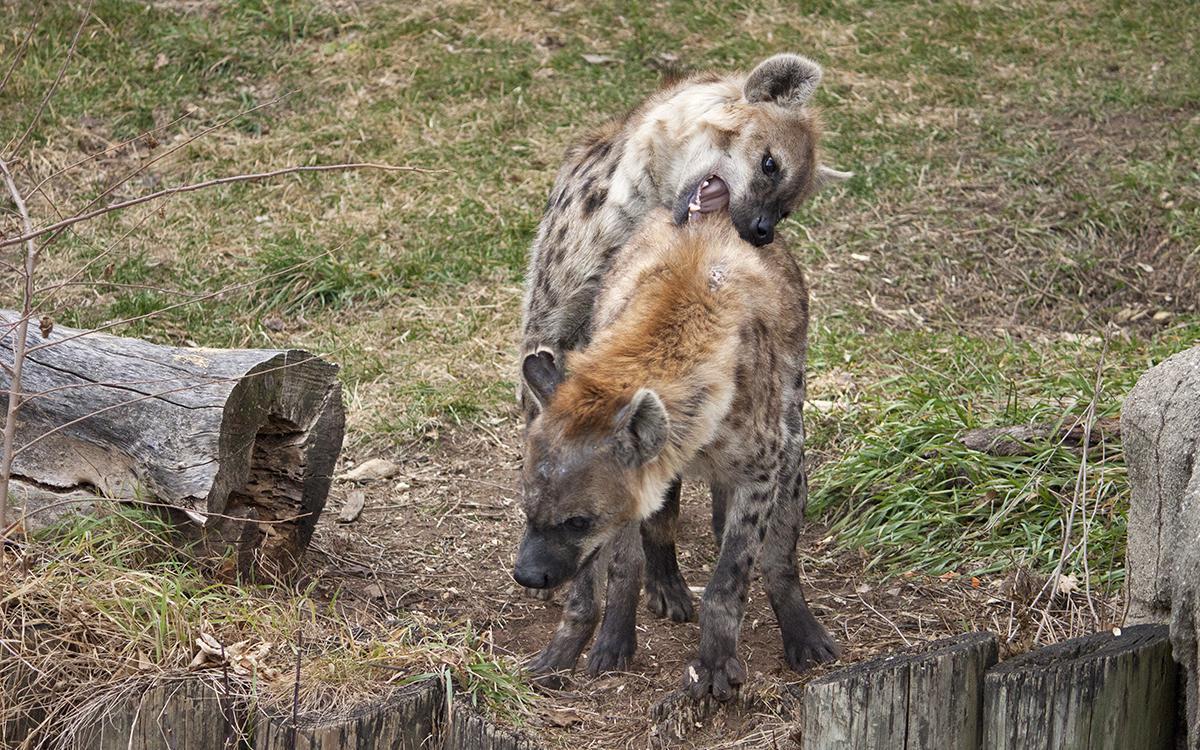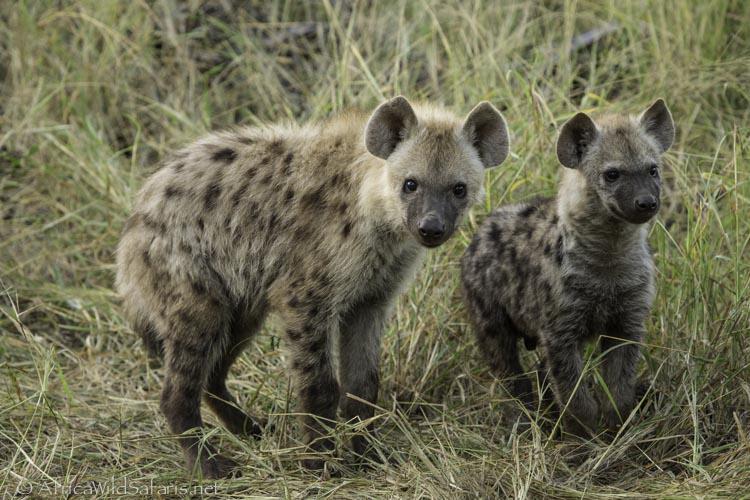The first image is the image on the left, the second image is the image on the right. Considering the images on both sides, is "Neither image shows a carcass near a hyena, and one image shows exactly two hyenas, with one behind the other." valid? Answer yes or no. Yes. The first image is the image on the left, the second image is the image on the right. Examine the images to the left and right. Is the description "none of the hyenas are eating, at the moment." accurate? Answer yes or no. Yes. 